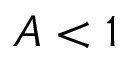<formula> <loc_0><loc_0><loc_500><loc_500>A < 1</formula> 